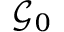<formula> <loc_0><loc_0><loc_500><loc_500>\mathcal { G } _ { 0 }</formula> 